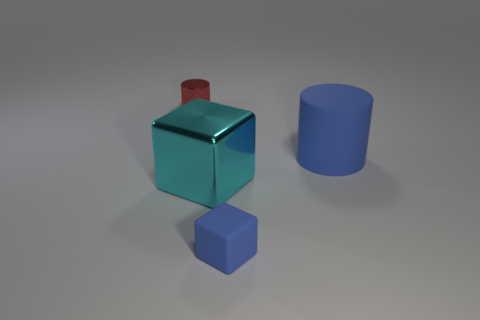There is a shiny thing in front of the cylinder that is behind the cylinder that is in front of the metallic cylinder; what is its shape?
Provide a short and direct response. Cube. What number of large cylinders have the same material as the red object?
Give a very brief answer. 0. There is a cube on the right side of the big metallic block; what number of blue objects are behind it?
Make the answer very short. 1. What number of big blue matte cylinders are there?
Make the answer very short. 1. Are the tiny red thing and the big object in front of the big blue rubber thing made of the same material?
Your answer should be very brief. Yes. Is the color of the small object that is on the left side of the big cyan shiny object the same as the shiny block?
Your response must be concise. No. What material is the object that is both behind the cyan shiny cube and to the right of the small red object?
Offer a terse response. Rubber. The blue matte cylinder has what size?
Keep it short and to the point. Large. There is a small block; does it have the same color as the matte thing behind the matte cube?
Your response must be concise. Yes. How many other things are there of the same color as the large rubber cylinder?
Offer a very short reply. 1. 